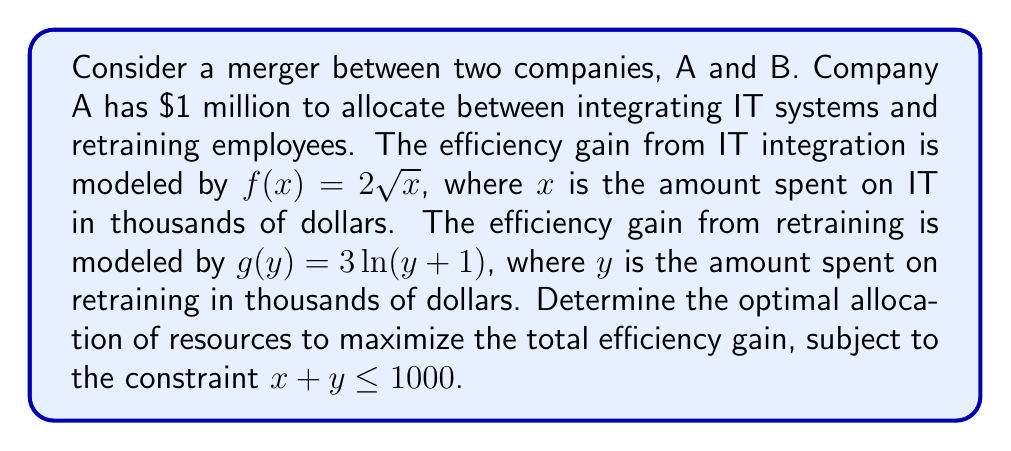Provide a solution to this math problem. To solve this optimal control problem, we'll use the method of Lagrange multipliers:

1) Define the objective function:
   $$F(x,y) = f(x) + g(y) = 2\sqrt{x} + 3\ln(y+1)$$

2) Define the constraint:
   $$x + y = 1000$$ (We use equality because we want to use all available resources)

3) Form the Lagrangian:
   $$L(x,y,\lambda) = 2\sqrt{x} + 3\ln(y+1) - \lambda(x + y - 1000)$$

4) Take partial derivatives and set them to zero:
   $$\frac{\partial L}{\partial x} = \frac{1}{\sqrt{x}} - \lambda = 0$$
   $$\frac{\partial L}{\partial y} = \frac{3}{y+1} - \lambda = 0$$
   $$\frac{\partial L}{\partial \lambda} = x + y - 1000 = 0$$

5) From the first two equations:
   $$\frac{1}{\sqrt{x}} = \frac{3}{y+1}$$

6) Solve for y:
   $$y = 3\sqrt{x} - 1$$

7) Substitute into the constraint:
   $$x + (3\sqrt{x} - 1) = 1000$$
   $$x + 3\sqrt{x} = 1001$$

8) Solve this equation numerically (e.g., using Newton's method):
   $$x \approx 563.72$$

9) Calculate y:
   $$y \approx 1000 - 563.72 = 436.28$$

Therefore, the optimal allocation is approximately $563,720 for IT integration and $436,280 for retraining.
Answer: The optimal control strategy is to allocate approximately $563,720 to IT integration and $436,280 to retraining employees. 